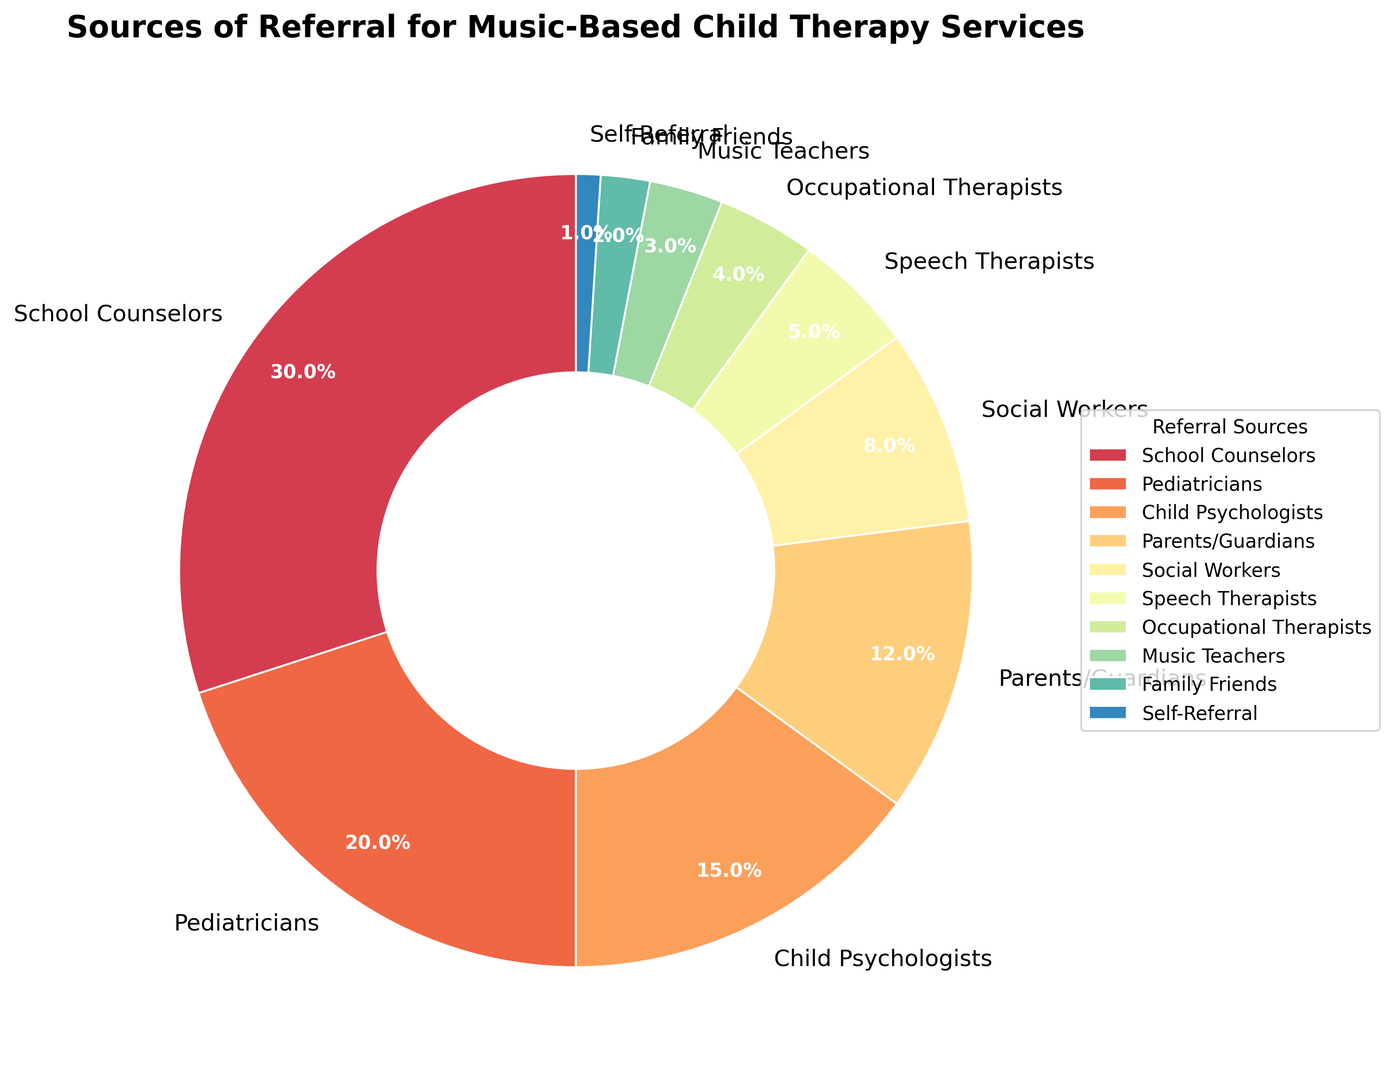What's the largest source of referrals for music-based child therapy services? By examining the pie chart, the segment labeled "School Counselors" occupies the largest portion of the pie chart. Therefore, the largest source of referrals can be directly observed.
Answer: School Counselors Which two sources combined contribute to more than 50% of referrals? Looking at the chart, the segments for "School Counselors" and "Pediatricians" are the largest and summing their percentages: School Counselors (30%) + Pediatricians (20%) = 50%. Since 50% is not greater than 50%, we need to add the next highest, "Child Psychologists (15%)" making School Counselors + Pediatricians + Child Psychologists = 65%. The first two combined don't make over 50%, but adding "Child Psychologists" does.
Answer: School Counselors and Pediatricians Which source of referral is the smallest? Observing the smallest segment of the pie chart, the label "Self-Referral" occupies the smallest area of the chart, representing the least amount of referrals.
Answer: Self-Referral How many sources of referrals have a percentage less than or equal to 5%? From the pie chart, examine the labels with percentages: Social Workers (8%), Speech Therapists (5%), Occupational Therapists (4%), Music Teachers (3%), Family Friends (2%), Self-Referral (1%). Count the ones with 5% and below which total up to 5 sources.
Answer: Five: Speech Therapists, Occupational Therapists, Music Teachers, Family Friends, Self-Referral What is the total percentage of referrals from School Counselors, Pediatricians, and Parents/Guardians? Adding the percentages of these referral sources: School Counselors (30%) + Pediatricians (20%) + Parents/Guardians (12%) = 62%. Therefore, the total percentage of referrals from these three sources is 62%.
Answer: 62% Which source contributes more to referrals: Occupational Therapists or Social Workers? Looking at the pie chart, the percentage for Social Workers is 8% and for Occupational Therapists is 4%. Since 8% is greater than 4%, Social Workers contribute more.
Answer: Social Workers What is the combined percentage for the least four sources of referrals? Identifying the smallest segments, we sum the percentages for Music Teachers (3%), Family Friends (2%), Self-Referral (1%) and Occupational Therapists (4%): 3% + 2% + 4% + 1% = 10%. Therefore, their combined percentage is 10%.
Answer: 10% Can the percentage for Social Workers be combined with that of Speech Therapists to be higher than Child Psychologists? Based on the pie chart, Social Workers have 8% and Speech Therapists have 5%. Adding them gives 8% + 5% = 13%, which is indeed higher than the 15% for Child Psychologists.
Answer: No 